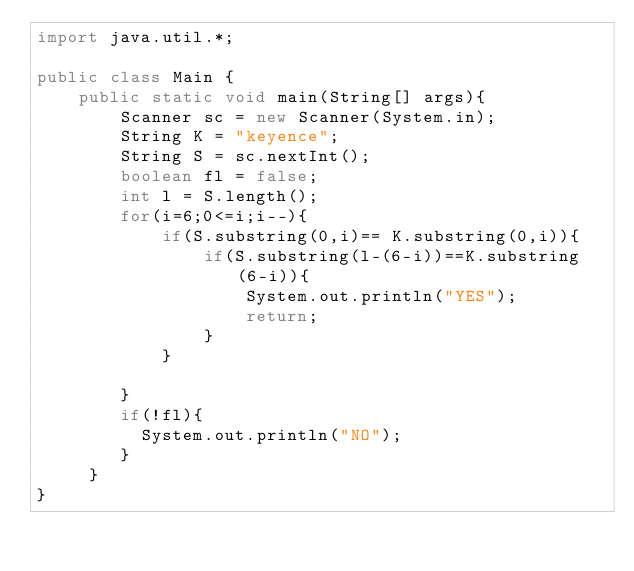<code> <loc_0><loc_0><loc_500><loc_500><_Java_>import java.util.*;
 
public class Main {
	public static void main(String[] args){
    	Scanner sc = new Scanner(System.in);
		String K = "keyence";
		String S = sc.nextInt();
        boolean fl = false;
        int l = S.length();
      	for(i=6;0<=i;i--){
        	if(S.substring(0,i)== K.substring(0,i)){
        		if(S.substring(l-(6-i))==K.substring(6-i)){
                	System.out.println("YES");
                  	return;
                }
            }
        
        }
      	if(!fl){
          System.out.println("NO");
        }
     } 
}  </code> 